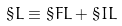Convert formula to latex. <formula><loc_0><loc_0><loc_500><loc_500>\S L \equiv \S F L + \S I L</formula> 